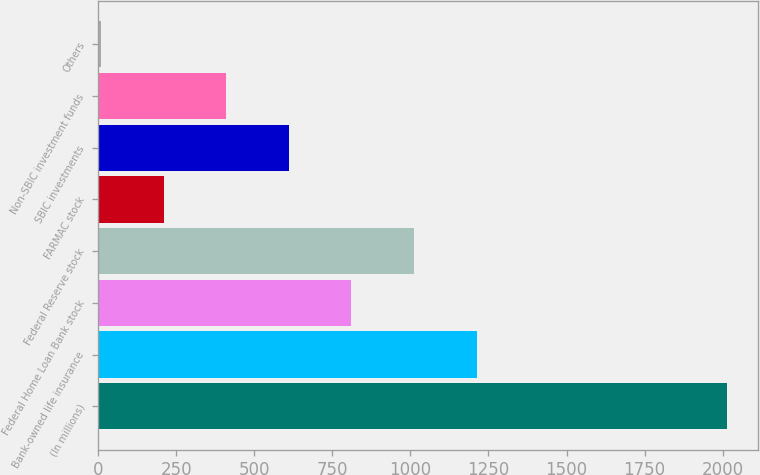Convert chart to OTSL. <chart><loc_0><loc_0><loc_500><loc_500><bar_chart><fcel>(In millions)<fcel>Bank-owned life insurance<fcel>Federal Home Loan Bank stock<fcel>Federal Reserve stock<fcel>FARMAC stock<fcel>SBIC investments<fcel>Non-SBIC investment funds<fcel>Others<nl><fcel>2014<fcel>1212<fcel>811<fcel>1011.5<fcel>209.5<fcel>610.5<fcel>410<fcel>9<nl></chart> 